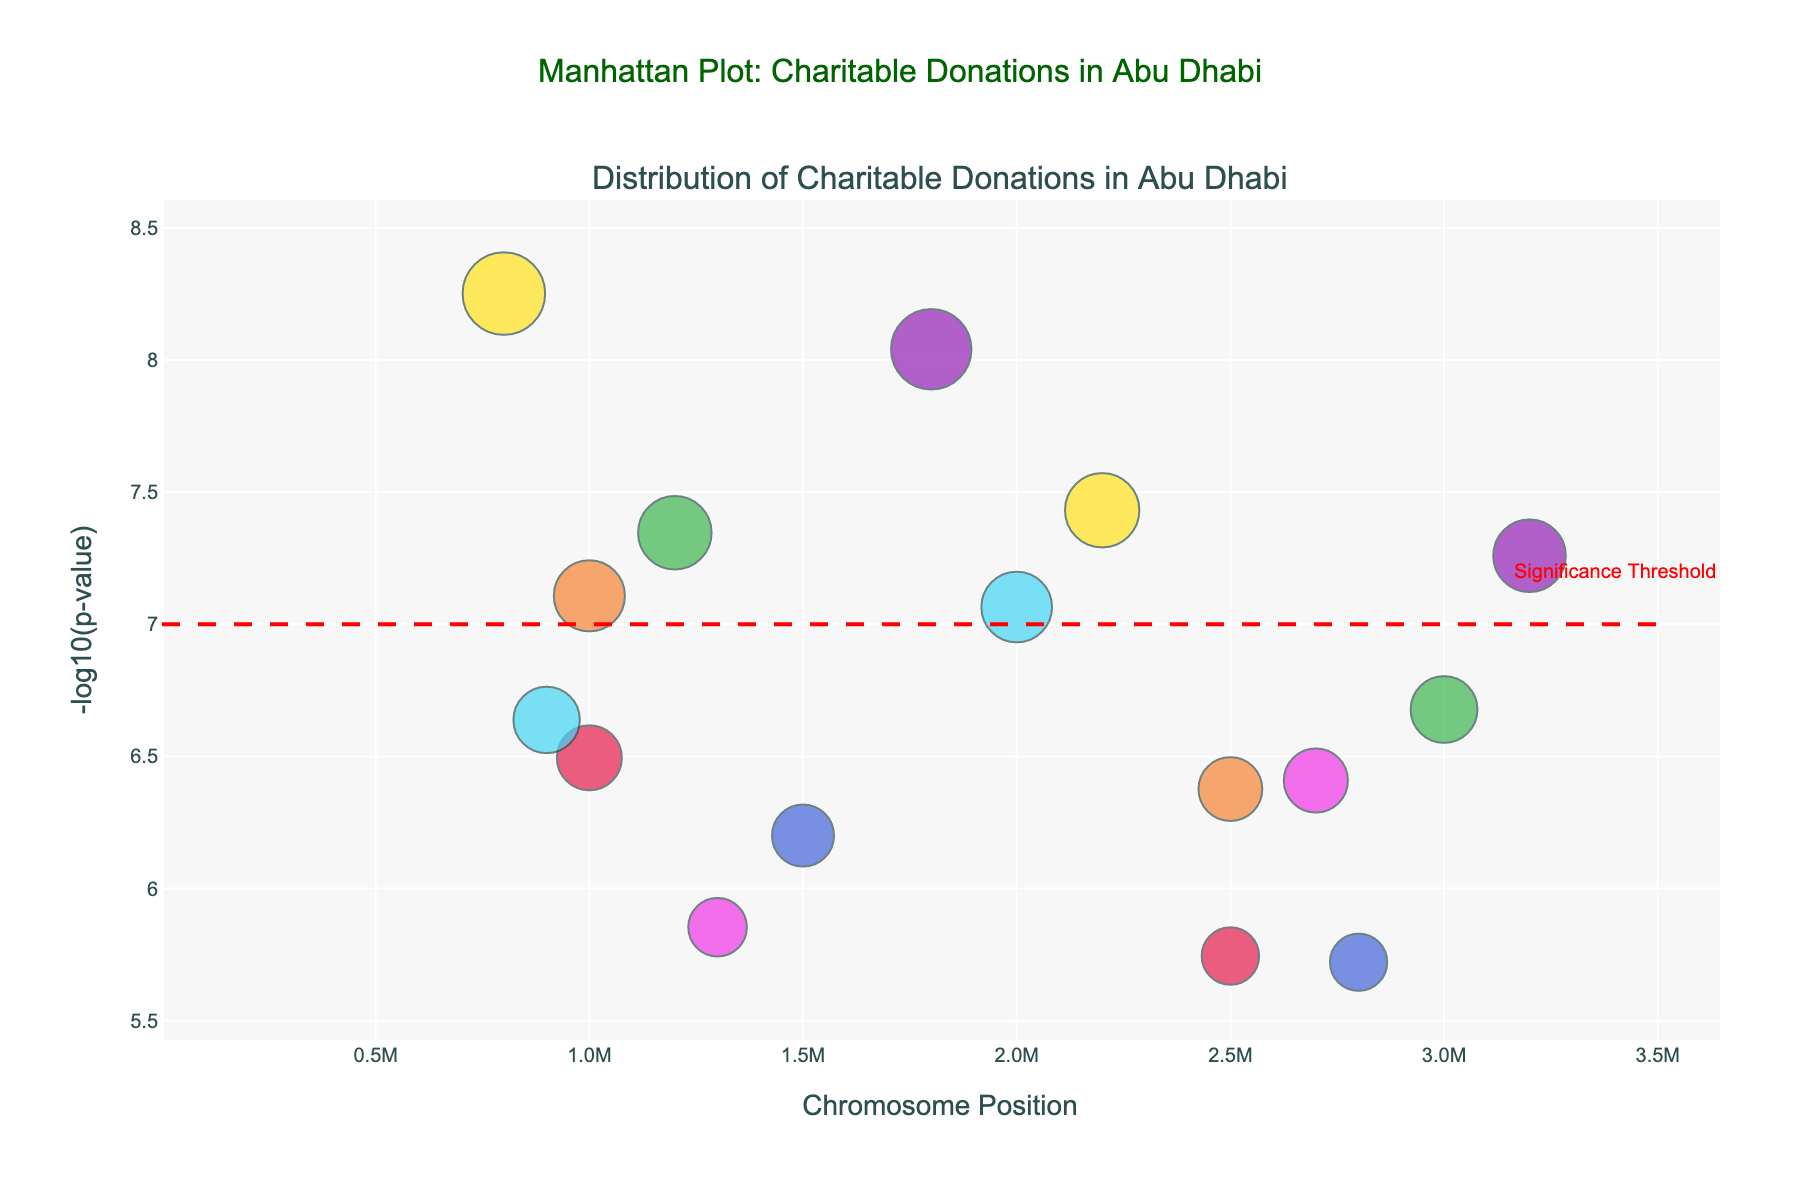What is the title of the figure? Look at the top center of the figure where the main title is displayed.
Answer: Manhattan Plot: Charitable Donations in Abu Dhabi How many chromosomes are represented in the plot? Count the unique labels on the x-axis representing different chromosomes.
Answer: 8 Which organization has the highest -log10(p-value) in Chromosome 3? Identify the tallest marker (highest y-value) in the section of the plot for Chromosome 3 and look at the hover text.
Answer: Emirates Red Crescent Is there any annotation or threshold line in the plot? Check for any horizontal lines or extra labels on the plot different from the regular data points.
Answer: Yes, there's a significance threshold line at -log10(p) = 7 What is the significance threshold line value set in the plot? Locate the horizontal line and read any labels or annotations that mention its value.
Answer: 7 Which chromosome has the most significant data points below the threshold? Compare the number of markers above the significance line for each chromosome.
Answer: Chromosome 3 How many organizations have a -log10(p-value) greater than 8? Count all the markers with a y-value above 8.
Answer: 2 Which organizations are represented in Chromosome 1? Identify the data points in the Chromosome 1 section of the plot and note the hover text for each.
Answer: Islamic Affairs and Charitable Activities Department, Zakat Fund Between Chromosome 2 and Chromosome 7, which has the smaller p-values on average? Examine the heights of the markers (y-values) for each chromosome and compute the average if needed. Higher y-values indicate smaller p-values.
Answer: Chromosome 7 What does the color of the data points indicate in the plot? Recognize that the colors distinguish different chromosomes, as the legend may show or through observation.
Answer: Different chromosomes 